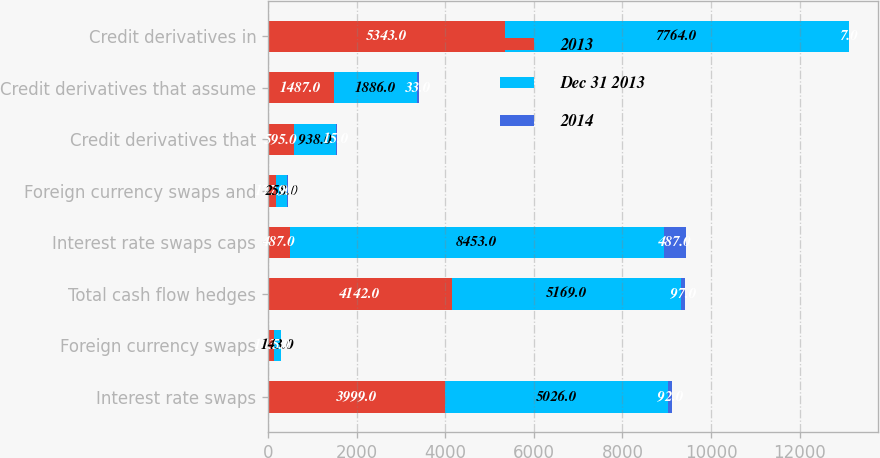Convert chart to OTSL. <chart><loc_0><loc_0><loc_500><loc_500><stacked_bar_chart><ecel><fcel>Interest rate swaps<fcel>Foreign currency swaps<fcel>Total cash flow hedges<fcel>Interest rate swaps caps<fcel>Foreign currency swaps and<fcel>Credit derivatives that<fcel>Credit derivatives that assume<fcel>Credit derivatives in<nl><fcel>2013<fcel>3999<fcel>143<fcel>4142<fcel>487<fcel>177<fcel>595<fcel>1487<fcel>5343<nl><fcel>Dec 31 2013<fcel>5026<fcel>143<fcel>5169<fcel>8453<fcel>258<fcel>938<fcel>1886<fcel>7764<nl><fcel>2014<fcel>92<fcel>5<fcel>97<fcel>487<fcel>9<fcel>15<fcel>33<fcel>7<nl></chart> 